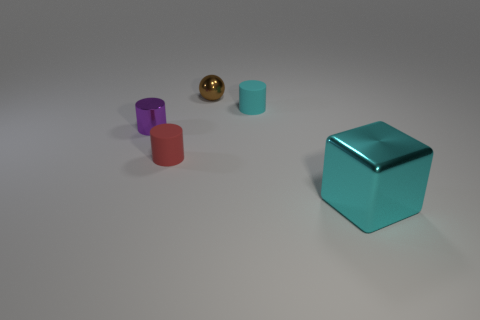Is the shiny ball the same color as the large metal object?
Provide a short and direct response. No. Is there any other thing that is the same shape as the red object?
Offer a terse response. Yes. Is there a shiny cylinder of the same color as the metal block?
Offer a terse response. No. Does the small object on the left side of the small red matte object have the same material as the tiny cylinder that is to the right of the brown sphere?
Your answer should be compact. No. What color is the tiny shiny cylinder?
Make the answer very short. Purple. How big is the metal thing to the right of the tiny metallic thing that is behind the cyan thing left of the large cube?
Ensure brevity in your answer.  Large. What number of other things are there of the same size as the red object?
Give a very brief answer. 3. How many purple cylinders are made of the same material as the brown object?
Provide a short and direct response. 1. There is a metal thing behind the small cyan rubber cylinder; what is its shape?
Your answer should be very brief. Sphere. Is the small purple cylinder made of the same material as the cylinder that is on the right side of the small red matte thing?
Your response must be concise. No. 